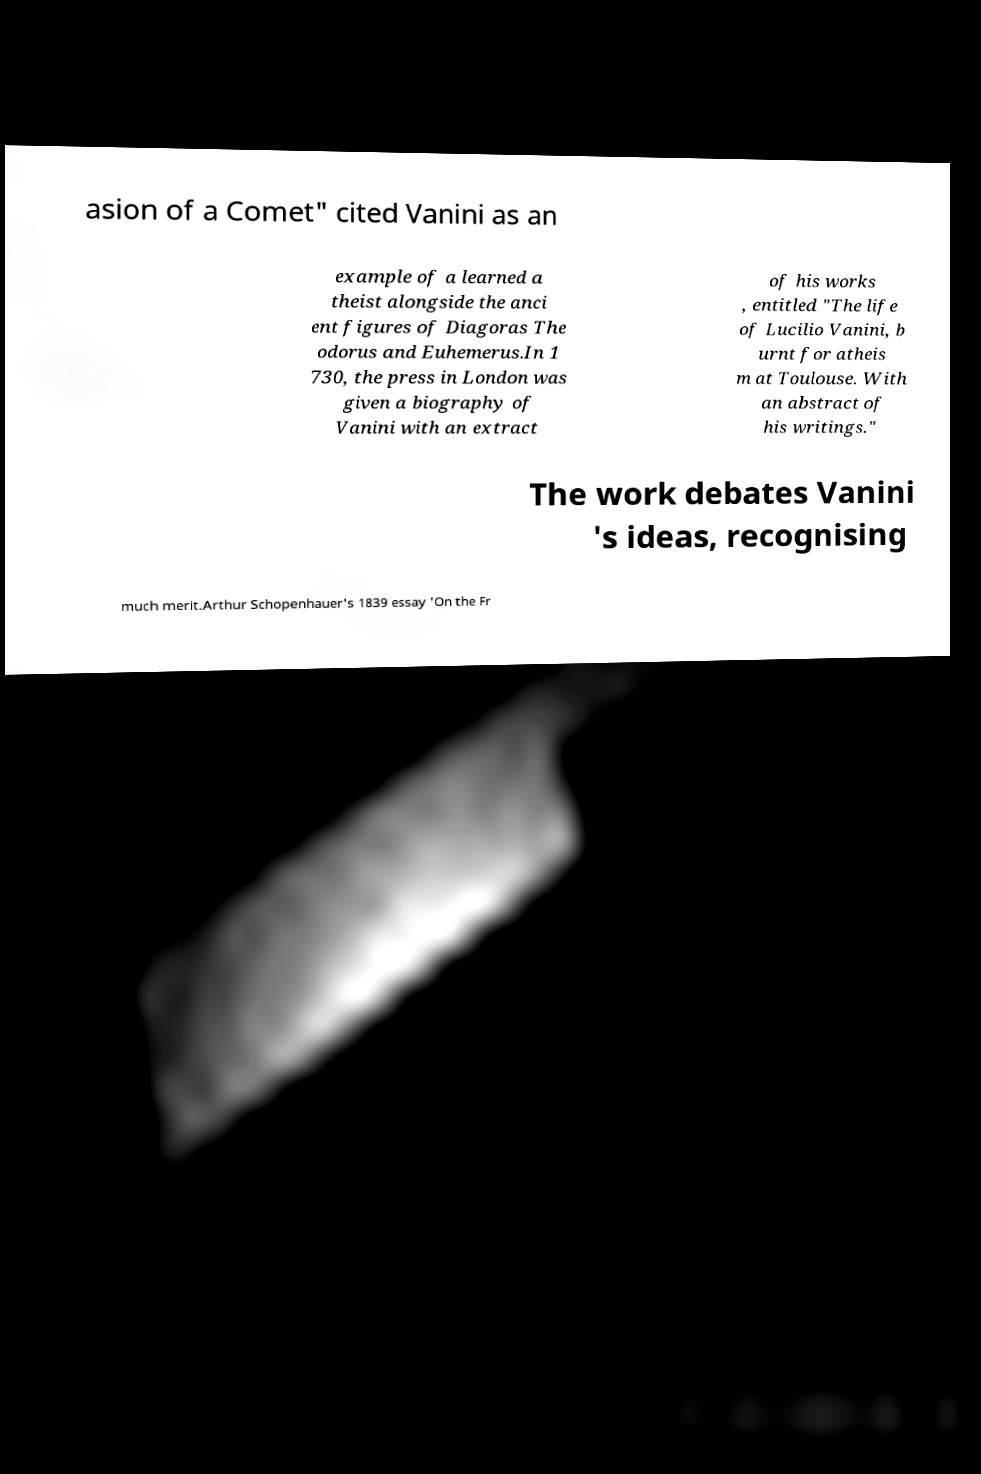Please identify and transcribe the text found in this image. asion of a Comet" cited Vanini as an example of a learned a theist alongside the anci ent figures of Diagoras The odorus and Euhemerus.In 1 730, the press in London was given a biography of Vanini with an extract of his works , entitled "The life of Lucilio Vanini, b urnt for atheis m at Toulouse. With an abstract of his writings." The work debates Vanini 's ideas, recognising much merit.Arthur Schopenhauer's 1839 essay 'On the Fr 